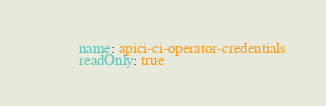Convert code to text. <code><loc_0><loc_0><loc_500><loc_500><_YAML_>          name: apici-ci-operator-credentials
          readOnly: true</code> 